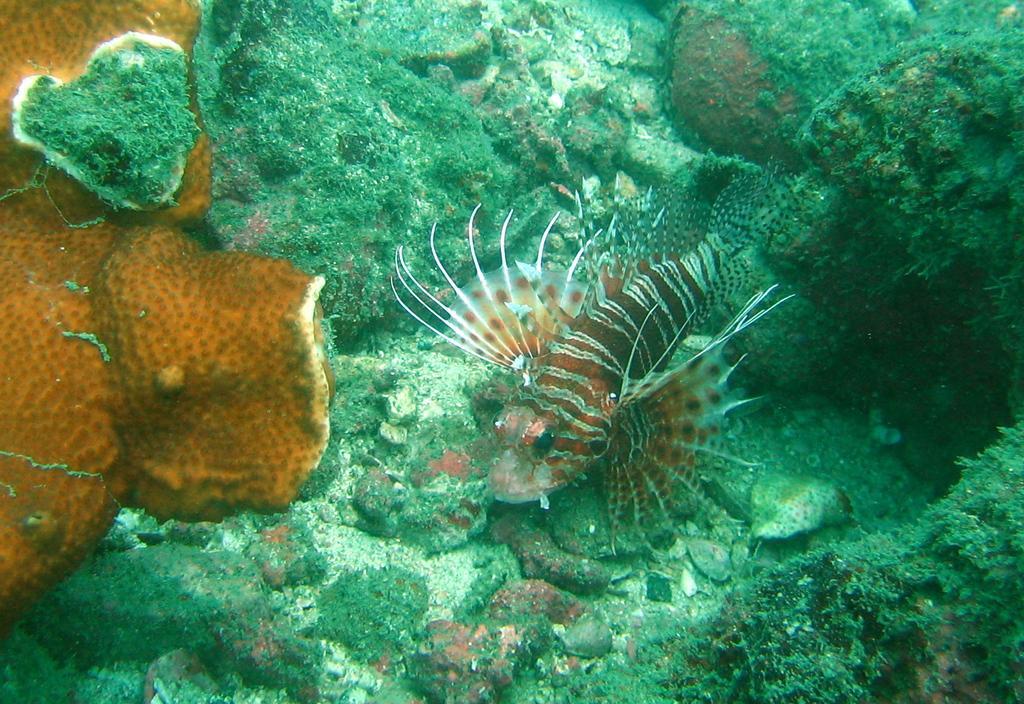Describe this image in one or two sentences. In the picture we can see a fish which is under water and there are some aquatic plants. 